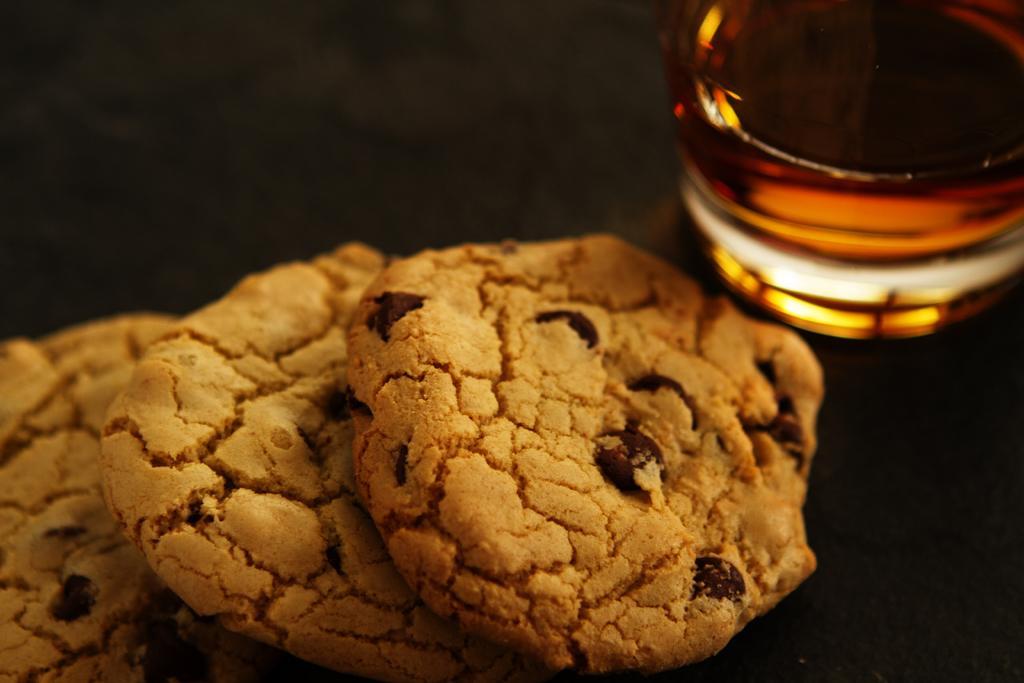Can you describe this image briefly? In this image I can see cookies and a glass object. These objects are on a black surface. 